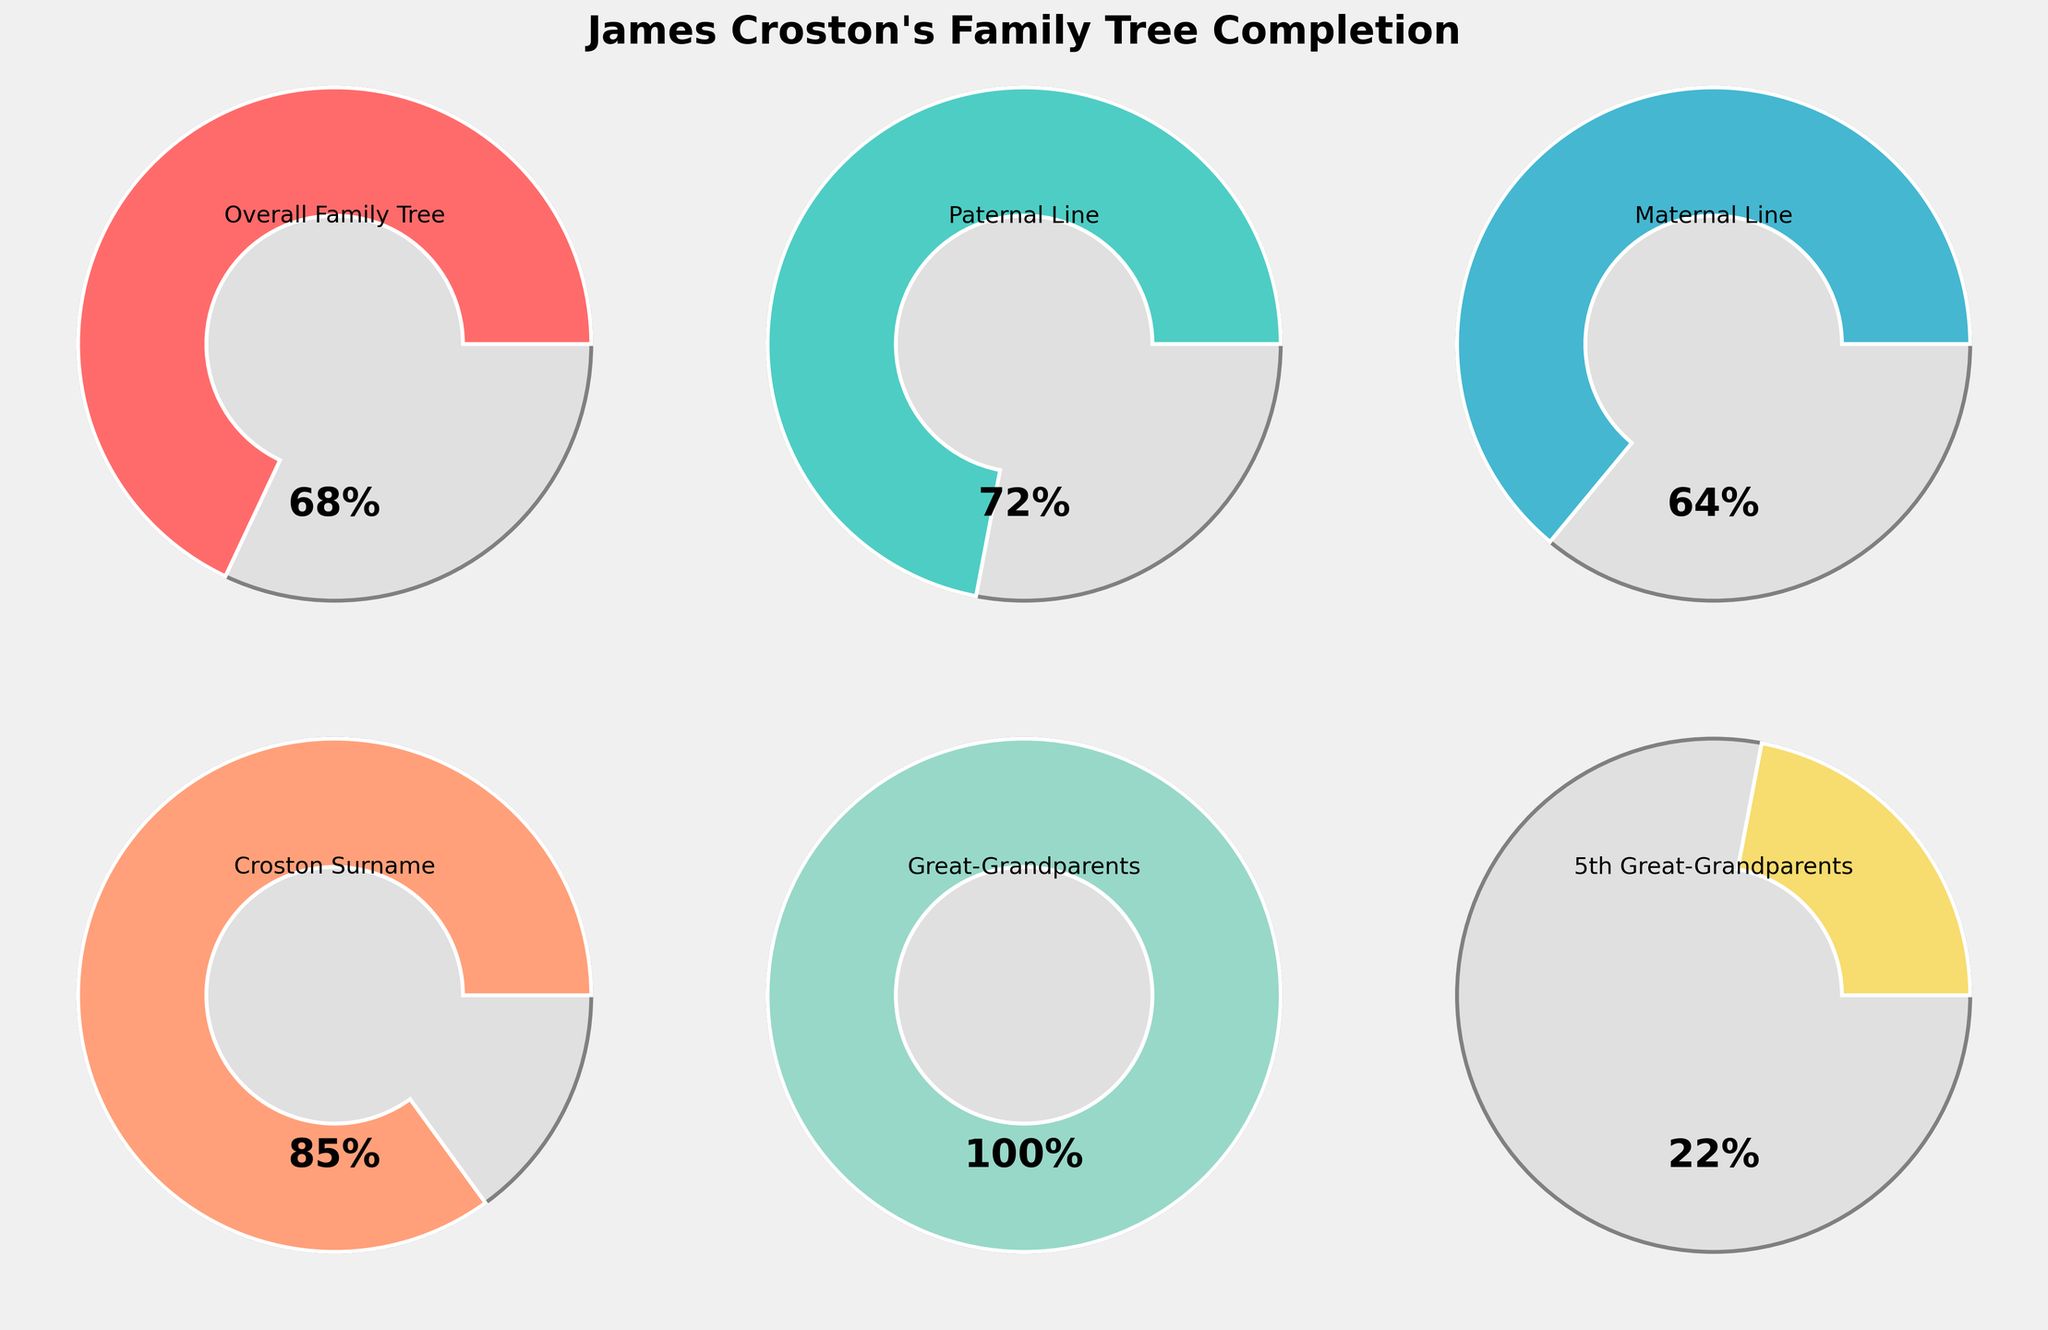Which category has the highest completion percentage? To find this, you look at each gauge and compare the completion percentages. The gauge with the highest percentage is for the Croston Surname with 85%.
Answer: Croston Surname What is the overall completion percentage of the family tree? The overall completion percentage is specifically shown in the gauge labeled "Overall Family Tree" which displays 68%.
Answer: 68% Which category has a completion percentage of 100%? By examining each gauge, both Great-Grandparents and Grandparents have a completion percentage of 100%.
Answer: Great-Grandparents and Grandparents How does the completion percentage of the Maternal Line compare to the Paternal Line? The Paternal Line has a completion percentage of 72%, while the Maternal Line has a completion percentage of 64%. The Paternal Line is 8 percentage points higher than the Maternal Line.
Answer: Paternal Line is 8% higher What is the difference between the completion percentages of the 2nd Great-Grandparents and the 5th Great-Grandparents? The 2nd Great-Grandparents have a completion percentage of 93%, while the 5th Great-Grandparents have 22%. The difference is 93% - 22% = 71%.
Answer: 71% Which category is closest to the overall family tree’s completion percentage? The overall family tree’s completion is 68%, and you compare this with other gauges. The Maternal Line is closest with 64%.
Answer: Maternal Line How many categories have a completion percentage above 70%? By scanning through the gauges, four categories have above 70%: Paternal Line (72%), Croston Surname (85%), Great-Grandparents (100%), and Grandparents (100%).
Answer: 4 Between the Croston Surname and the 3rd Great-Grandparents, which one has a higher completion percentage? The Croston Surname has an 85% completion, whereas the 3rd Great-Grandparents have 62%. Thus, the Croston Surname is higher by 23%.
Answer: Croston Surname What is the average completion percentage of the Paternal Line, Maternal Line, and the Overall Family Tree? You find the average by adding percentages of Paternal Line (72%), Maternal Line (64%), and Overall Family Tree (68%), then dividing by the number of categories: (72+64+68)/3 = 204/3 = 68%.
Answer: 68% 